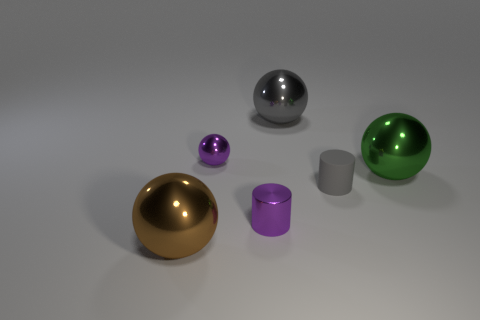What is the size of the cylinder that is the same color as the tiny shiny ball?
Your answer should be compact. Small. What number of shiny balls are the same color as the matte thing?
Your response must be concise. 1. Is the metallic cylinder the same color as the small metal sphere?
Make the answer very short. Yes. Is the number of gray balls that are to the left of the purple metallic sphere the same as the number of metallic objects to the right of the small gray matte cylinder?
Ensure brevity in your answer.  No. The rubber object has what color?
Provide a succinct answer. Gray. What number of things are either gray metallic spheres on the right side of the brown sphere or big red spheres?
Offer a very short reply. 1. Does the purple metal object that is in front of the purple metallic ball have the same size as the purple thing that is behind the large green thing?
Ensure brevity in your answer.  Yes. Is there anything else that has the same material as the tiny gray cylinder?
Your answer should be very brief. No. How many objects are either large shiny things left of the green shiny sphere or metallic things that are on the left side of the small purple metallic ball?
Offer a very short reply. 2. Is the brown object made of the same material as the tiny cylinder that is behind the tiny purple metallic cylinder?
Make the answer very short. No. 